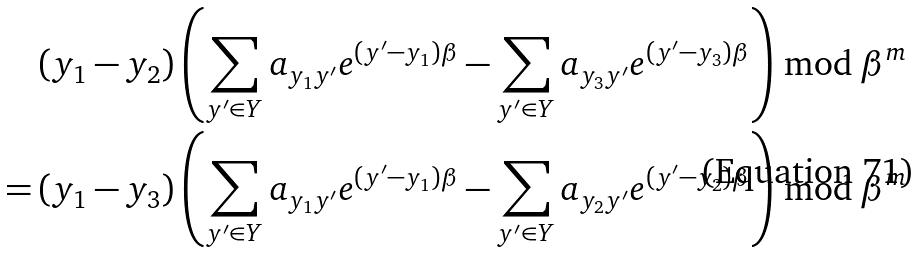Convert formula to latex. <formula><loc_0><loc_0><loc_500><loc_500>& \left ( y _ { 1 } - y _ { 2 } \right ) \left ( \sum _ { y ^ { \prime } \in Y } a _ { y _ { 1 } y ^ { \prime } } e ^ { ( y ^ { \prime } - y _ { 1 } ) \beta } - \sum _ { y ^ { \prime } \in Y } a _ { y _ { 3 } y ^ { \prime } } e ^ { ( y ^ { \prime } - y _ { 3 } ) \beta } \right ) \bmod \beta ^ { m } \\ = & \left ( y _ { 1 } - y _ { 3 } \right ) \left ( \sum _ { y ^ { \prime } \in Y } a _ { y _ { 1 } y ^ { \prime } } e ^ { ( y ^ { \prime } - y _ { 1 } ) \beta } - \sum _ { y ^ { \prime } \in Y } a _ { y _ { 2 } y ^ { \prime } } e ^ { ( y ^ { \prime } - y _ { 2 } ) \beta } \right ) \bmod \beta ^ { m }</formula> 